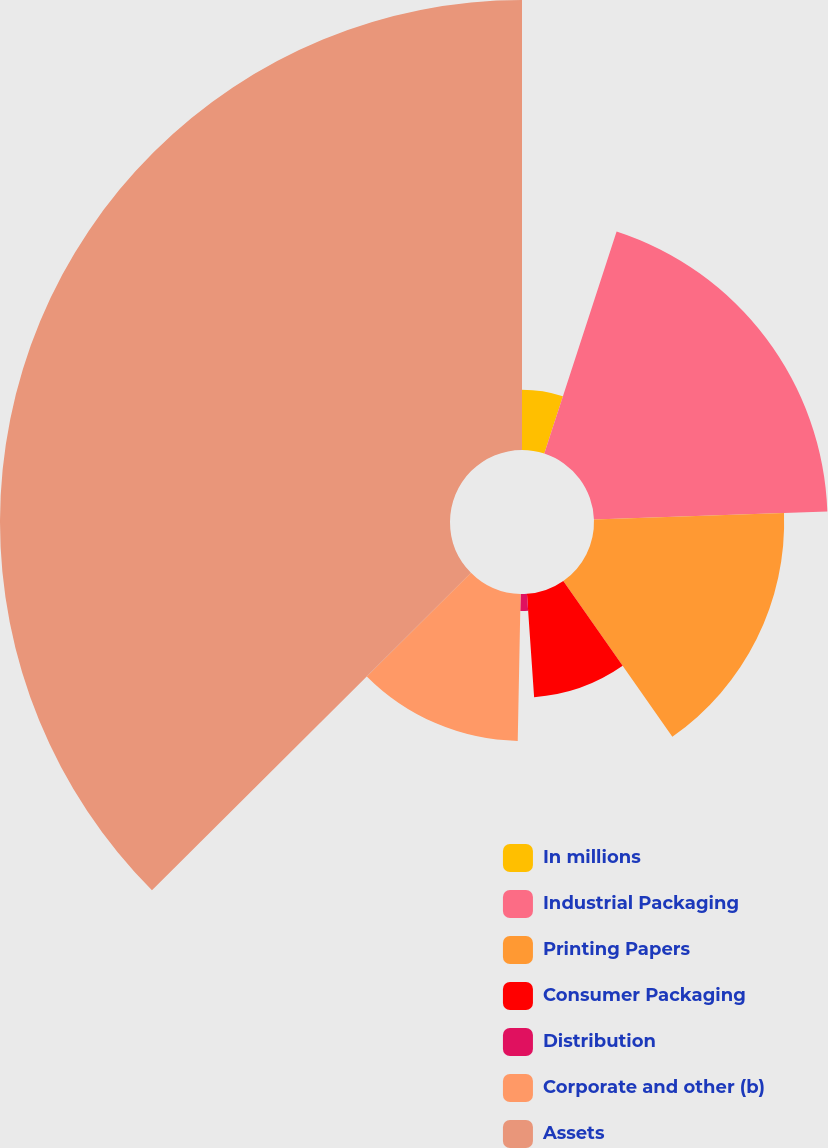Convert chart. <chart><loc_0><loc_0><loc_500><loc_500><pie_chart><fcel>In millions<fcel>Industrial Packaging<fcel>Printing Papers<fcel>Consumer Packaging<fcel>Distribution<fcel>Corporate and other (b)<fcel>Assets<nl><fcel>5.01%<fcel>19.44%<fcel>15.83%<fcel>8.62%<fcel>1.41%<fcel>12.23%<fcel>37.46%<nl></chart> 